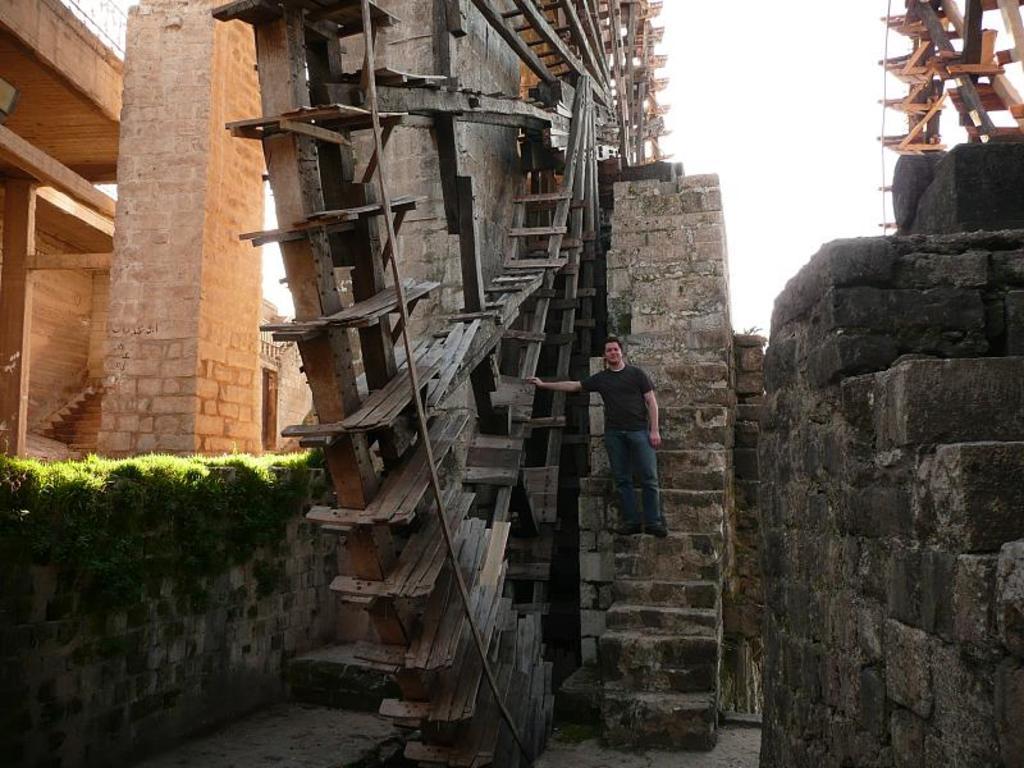Can you describe this image briefly? In this image I can see a person wearing black t shirt and blue jeans is standing on stairs and I can see a giant wooden wheel beside him. In the background I can see a building, some grass on the wall, a wooden structure and the sky. 